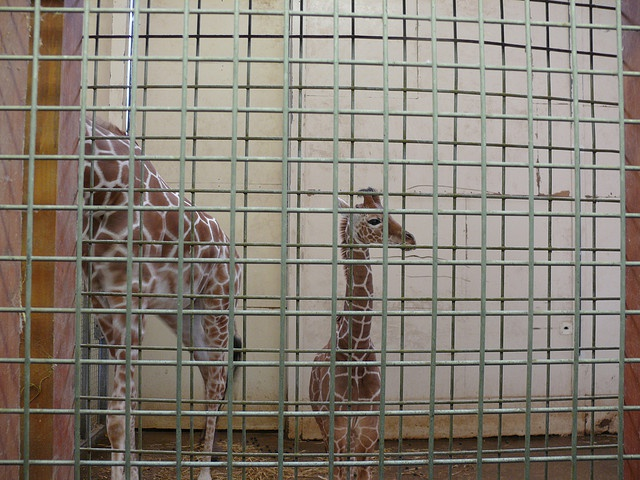Describe the objects in this image and their specific colors. I can see giraffe in gray, darkgray, maroon, and black tones and giraffe in gray, maroon, and black tones in this image. 